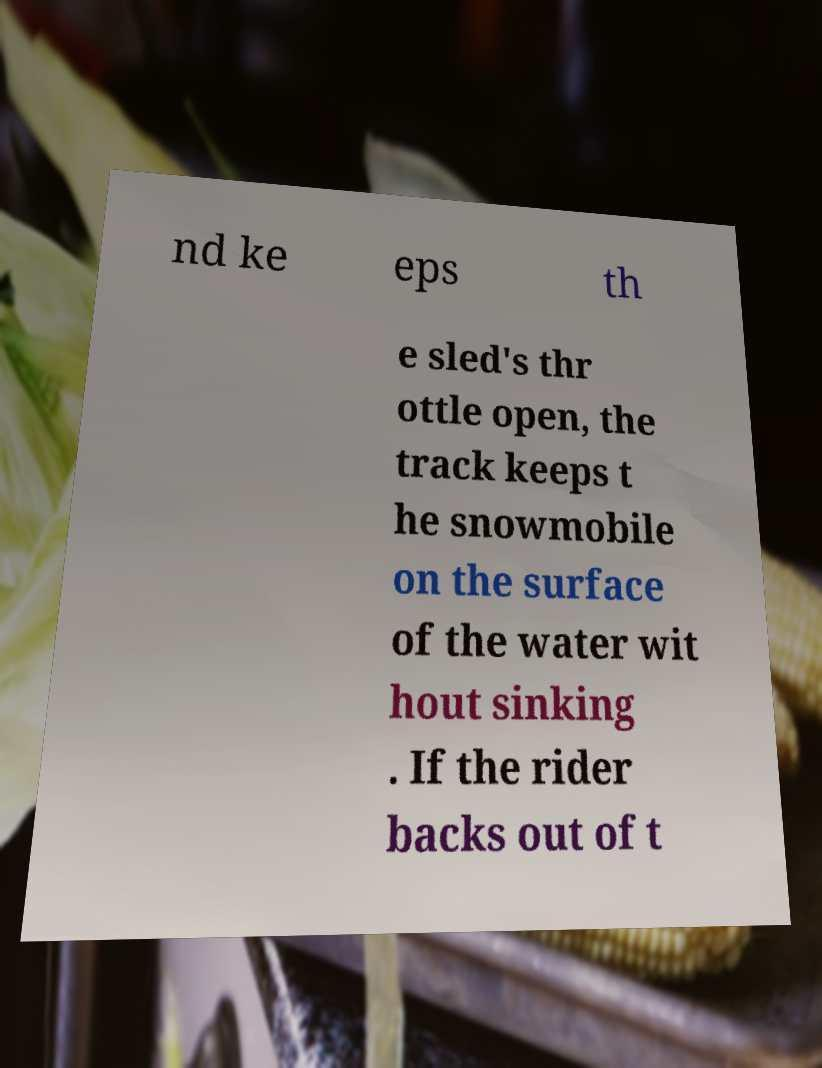Could you assist in decoding the text presented in this image and type it out clearly? nd ke eps th e sled's thr ottle open, the track keeps t he snowmobile on the surface of the water wit hout sinking . If the rider backs out of t 